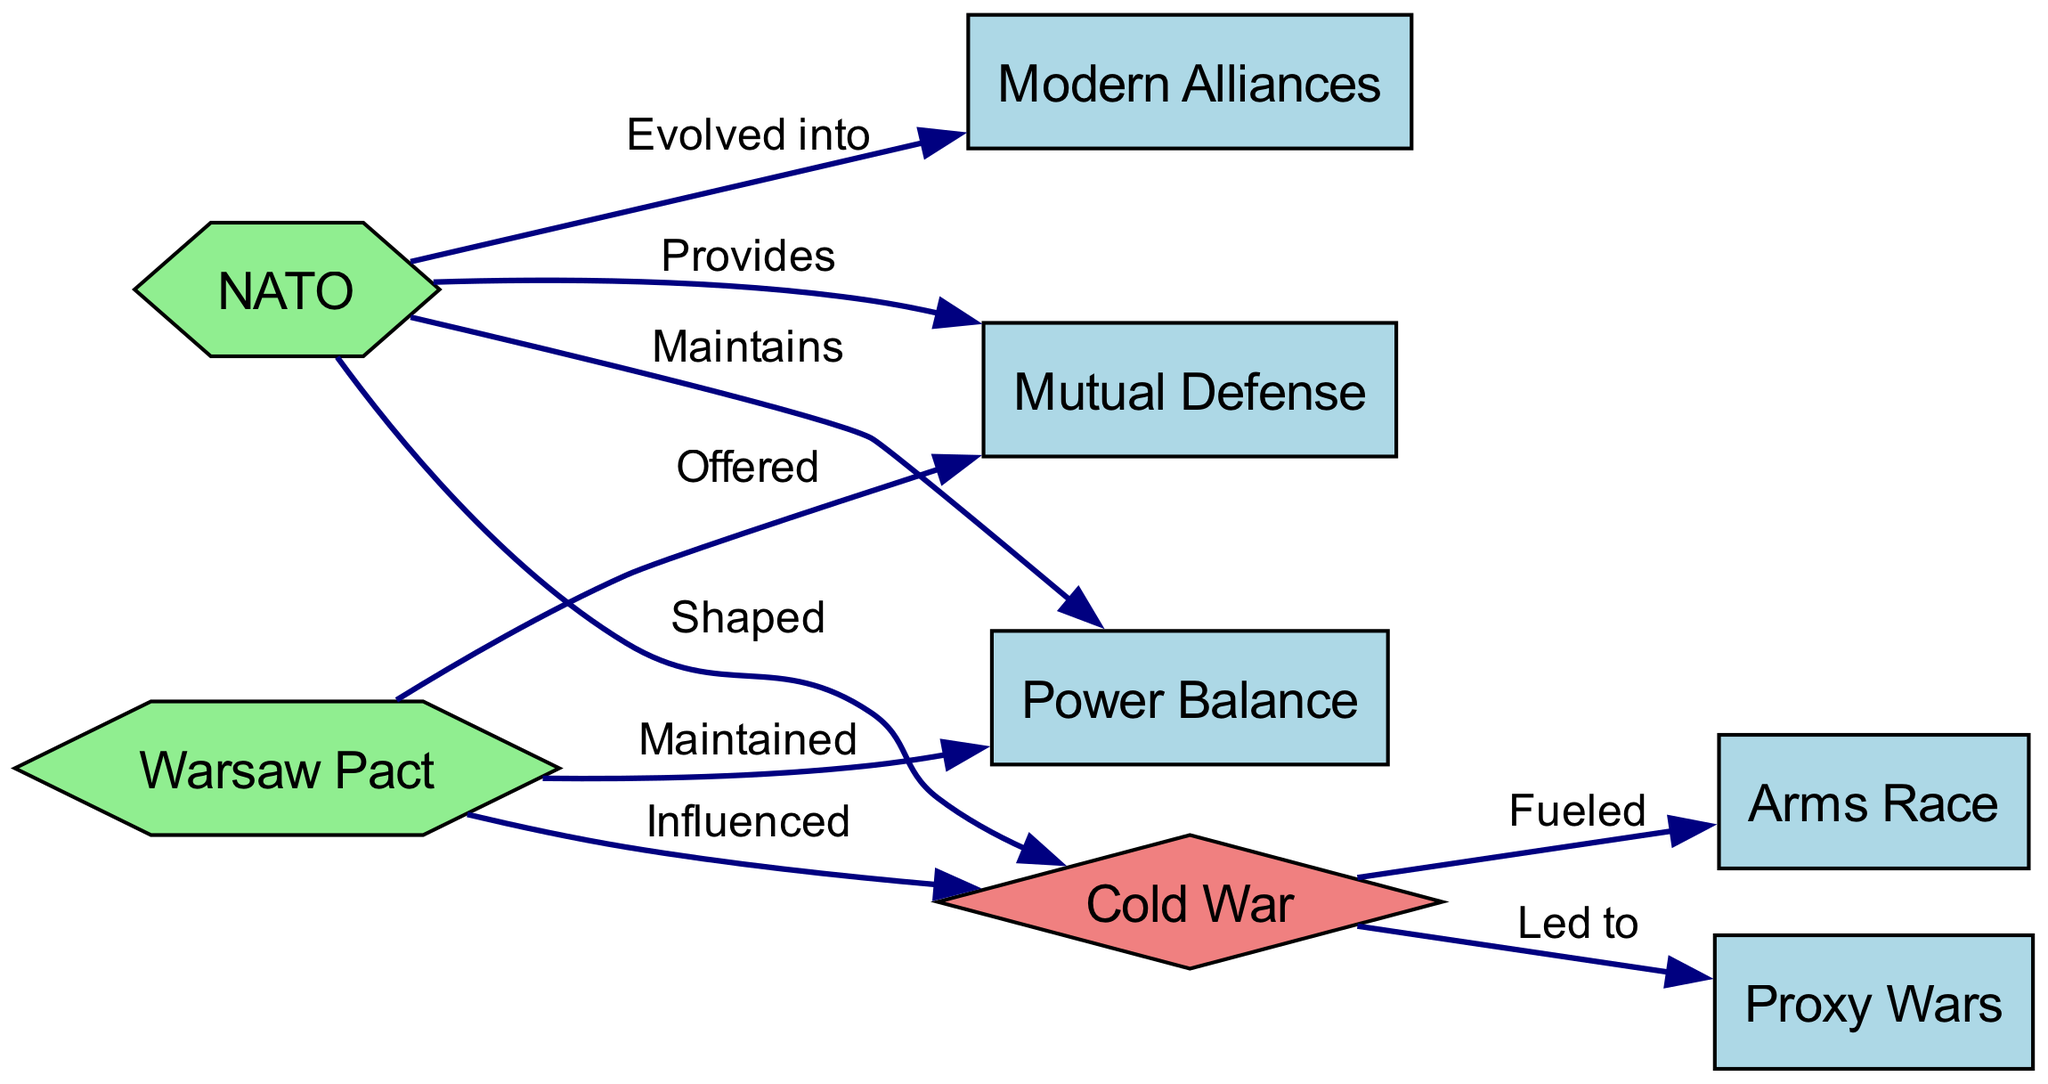What military alliance is represented in green and influences the Cold War? In the diagram, both NATO and the Warsaw Pact are represented as military alliances. The Warsaw Pact is explicitly labeled with the edge "Influenced" pointing towards the Cold War, indicating its role in shaping that period.
Answer: Warsaw Pact How many nodes are present in the diagram? The diagram features a total of 8 nodes according to the provided data, which include NATO, Warsaw Pact, Cold War, Mutual Defense, Power Balance, Arms Race, Proxy Wars, and Modern Alliances.
Answer: 8 What type of defense does NATO provide? The diagram indicates a direct link from NATO to Mutual Defense, where it is labeled "Provides," showing that NATO is responsible for mutual defense among its members.
Answer: Mutual Defense Which two concepts did the Cold War fuel according to the diagram? The edges leading from Cold War show "Fueled" connecting to Arms Race and "Led to" connecting to Proxy Wars, indicating these two conflicts arose as a result of the Cold War dynamics.
Answer: Arms Race and Proxy Wars What has NATO evolved into according to the diagram? The diagram has an edge from NATO labeled "Evolved into" that points towards Modern Alliances, indicating that NATO has transformed into a more contemporary form of alliances in global politics.
Answer: Modern Alliances What role did the Warsaw Pact play in maintaining global power dynamics? According to the diagram, the Warsaw Pact is linked to Power Balance with the label "Maintained," indicating that it played a significant role in sustaining that balance during its existence.
Answer: Maintained How did the Cold War affect military conflicts? The diagram points out that the Cold War "Fueled" the Arms Race and "Led to" Proxy Wars, showing that it directly influenced the nature and occurrence of various military conflicts.
Answer: Fueled Arms Race and Led to Proxy Wars What is the nature of the nodes representing NATO and the Warsaw Pact? In the diagram, NATO and the Warsaw Pact are visually represented as hexagons, which differentiates them from the diamond-shaped Cold War node, indicating their specific roles as military alliances.
Answer: Hexagon What does the Cold War signify according to the relationships shown in the diagram? The Cold War acts as a central theme in the diagram, influencing various military strategies, as seen in its connections to both the Arms Race and Proxy Wars, reflecting its significance in military history.
Answer: Central theme 